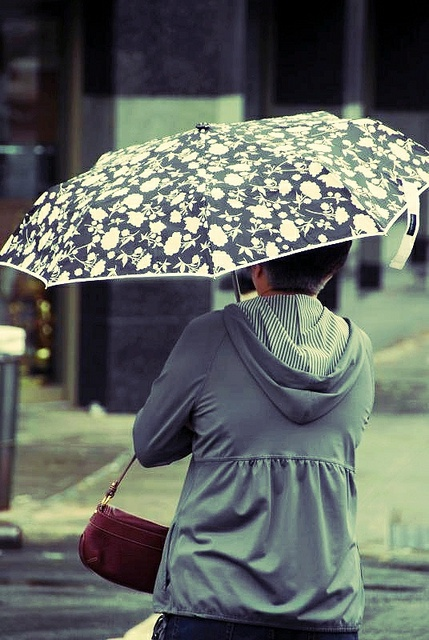Describe the objects in this image and their specific colors. I can see people in black, gray, and darkgray tones, umbrella in black, beige, gray, and darkgray tones, and handbag in black, maroon, gray, and purple tones in this image. 